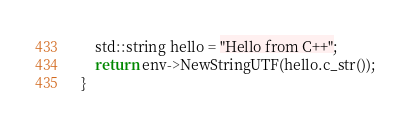<code> <loc_0><loc_0><loc_500><loc_500><_C++_>    std::string hello = "Hello from C++";
    return env->NewStringUTF(hello.c_str());
}
</code> 